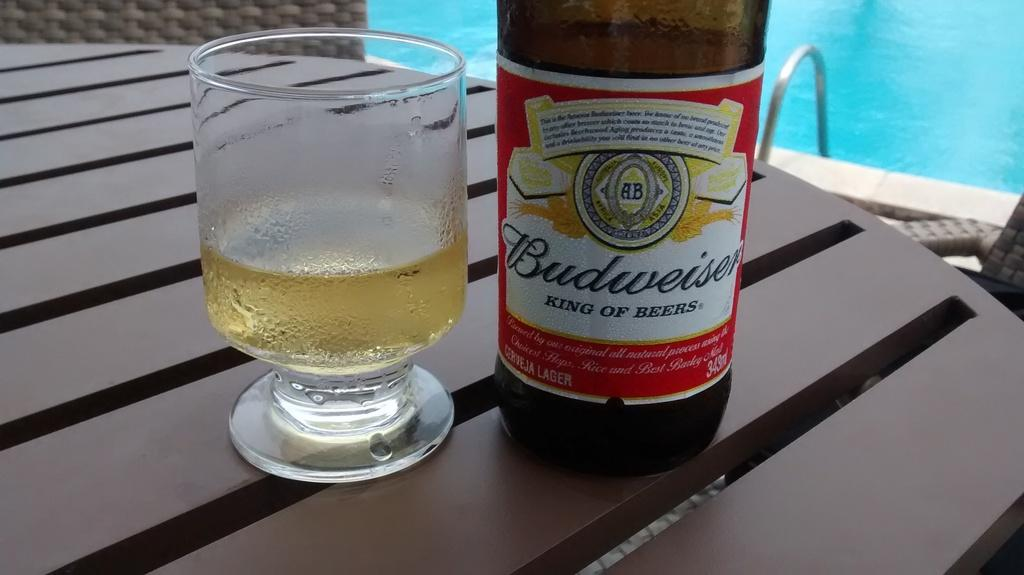What is on the table in the image? There is a glass and a bottle on the table in the image. What can be seen in the background of the image? There is a swimming pool in the image. What type of plants are growing in the basin near the swimming pool? There is no basin or plants present in the image; it only features a glass, a bottle, and a swimming pool. 